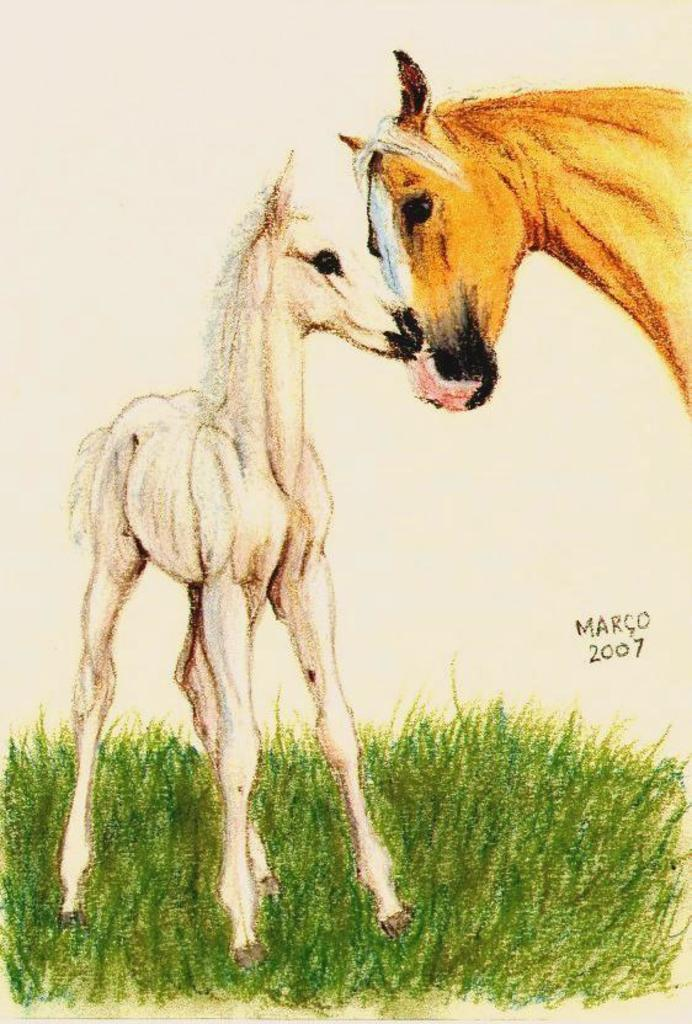What animals can be seen in the image? There is a horse and a pony in the image. What type of environment are the animals in? There is grass in the image, suggesting a natural outdoor setting. What type of badge is the horse wearing in the image? There is no badge visible on the horse in the image. How does the pony react to the unit in the image? There is no unit present in the image, so the pony's reaction cannot be determined. 